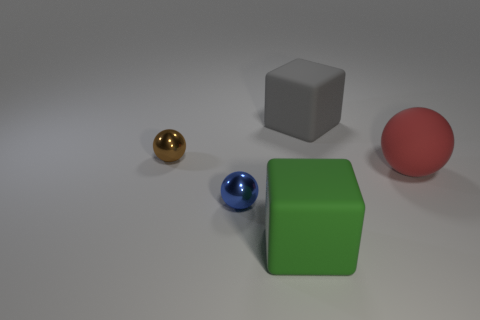Add 2 yellow things. How many objects exist? 7 Subtract all cubes. How many objects are left? 3 Add 4 green matte cubes. How many green matte cubes exist? 5 Subtract 0 red cylinders. How many objects are left? 5 Subtract all red matte spheres. Subtract all big brown metallic blocks. How many objects are left? 4 Add 3 matte spheres. How many matte spheres are left? 4 